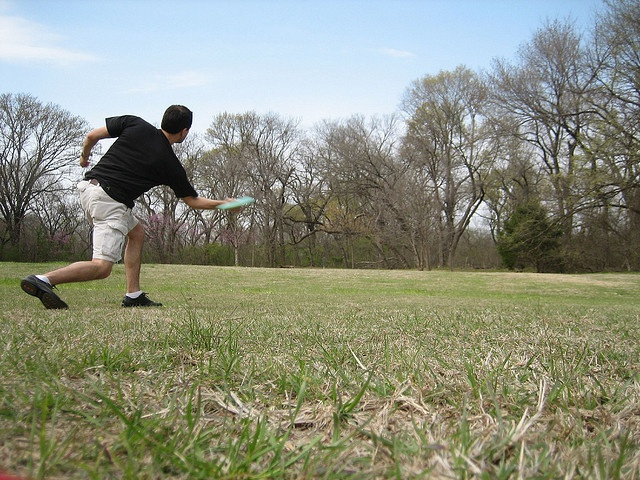Describe the objects in this image and their specific colors. I can see people in lavender, black, gray, darkgray, and lightgray tones and frisbee in lavender, lightblue, darkgray, turquoise, and gray tones in this image. 